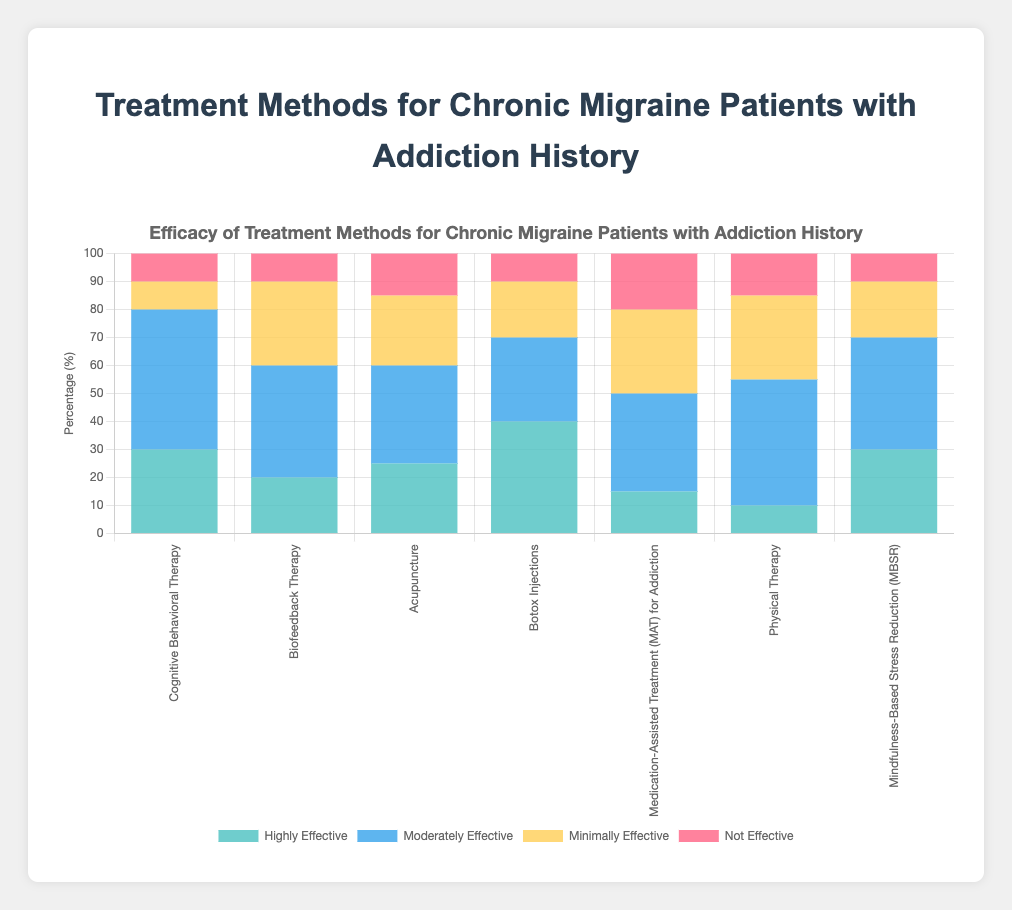Which treatment method is considered "Highly Effective" by the highest percentage of patients? The bar for "Botox Injections" is the tallest among the "Highly Effective" categories, indicating it has the highest percentage.
Answer: Botox Injections How does the effectiveness of "Biofeedback Therapy" compare to "Mindfulness-Based Stress Reduction (MBSR)" for the "Minimally Effective" category? The "Minimally Effective" bar for "Biofeedback Therapy" is taller than that for "Mindfulness-Based Stress Reduction (MBSR)", indicating a higher percentage.
Answer: Higher What is the total percentage of patients who found "Acupuncture" to be either "Minimally Effective" or "Not Effective"? The "Minimally Effective" bar is 25% and the "Not Effective" bar is 15%. Adding these gives 25% + 15% = 40%.
Answer: 40% Which treatment has an equal percentage of patients considering it "Not Effective" and "Moderately Effective"? For "Cognitive Behavioral Therapy", both the "Not Effective" and "Minimally Effective" bars seem to be at 10%, indicating an equal percentage.
Answer: Cognitive Behavioral Therapy What is the sum of patients who found "Physical Therapy" to be "Highly Effective" and "Moderately Effective"? The "Highly Effective" bar is 10% and the "Moderately Effective" bar is 45%. Adding these gives 10% + 45% = 55%.
Answer: 55% Which treatment methods have a "Not Effective" percentage lower than 15%? By visually inspecting the "Not Effective" bars, the treatment methods under 15% are "Cognitive Behavioral Therapy", "Biofeedback Therapy", "Botox Injections", "Mindfulness-Based Stress Reduction (MBSR)".
Answer: Cognitive Behavioral Therapy, Biofeedback Therapy, Botox Injections, Mindfulness-Based Stress Reduction (MBSR) Compare the number of "Highly Effective" responses between "Acupuncture" and "Medication-Assisted Treatment (MAT) for Addiction". The "Highly Effective" percentage for "Acupuncture" is 25%, and for "Medication-Assisted Treatment (MAT) for Addiction" it is 15%.
Answer: Acupuncture is higher Which treatment method has the highest sum of "Highly Effective" and "Moderately Effective" responses combined? Adding the "Highly Effective" and "Moderately Effective" percentages for each treatment, "Botox Injections" has the highest sum (40% + 30% = 70%).
Answer: Botox Injections What is the average percentage for the "Highly Effective" responses across all treatment methods? Adding the "Highly Effective" percentages (30% + 20% + 25% + 40% + 15% + 10% + 30%) and dividing by the number of methods (7), (30+20+25+40+15+10+30)/7 = 170/7 ≈ 24.29%.
Answer: 24.29% 